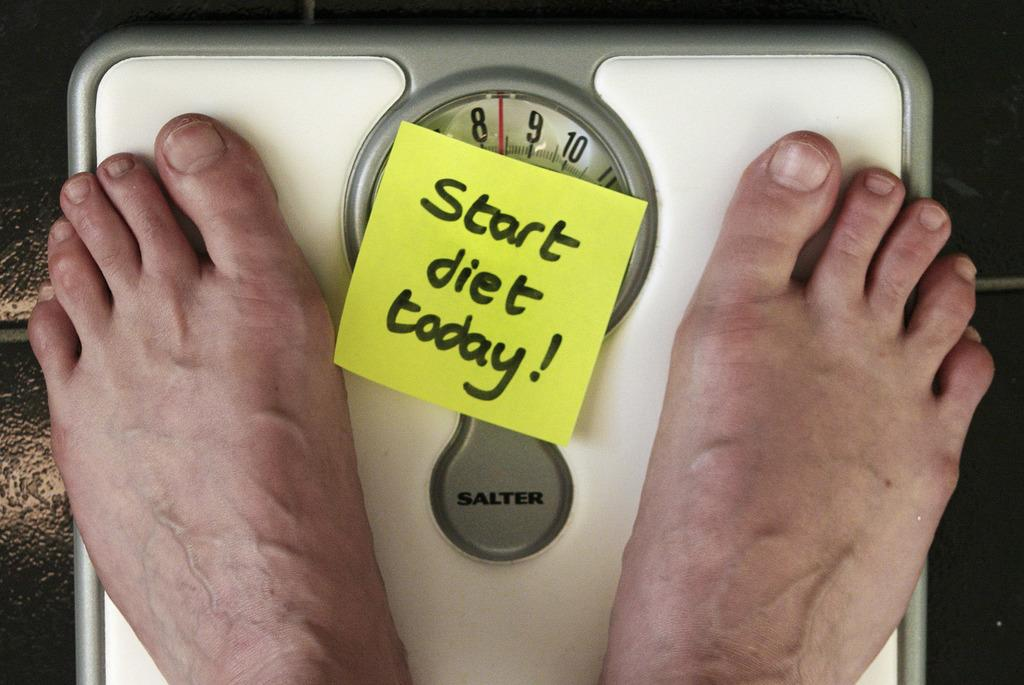What object is the main focus of the image? There is a weighing machine in the image. What is the person doing with the weighing machine? A person's feet are on the weighing machine. Is there any additional information provided in the image? Yes, there is a paper with something written in the image. What type of sign can be seen in the image? There is no sign present in the image; it features a weighing machine and a person standing on it, along with a paper with writing. 